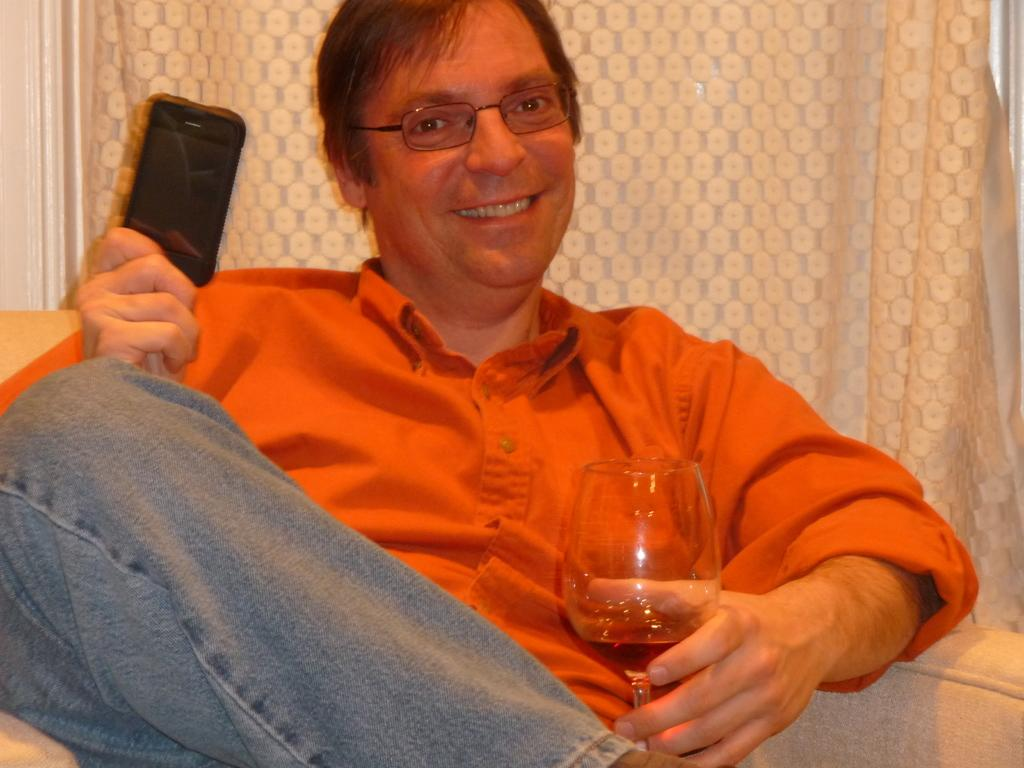What is the main subject of the picture? The main subject of the picture is a man. What is the man doing in the image? The man is sitting on a chair in the image. What is the man holding in his hands? The man is holding a glass and a phone in his hands. What can be seen in the background of the image? There is a cream curtain in the background of the image. What book is the man reading in the image? There is no book present in the image; the man is holding a glass and a phone. 